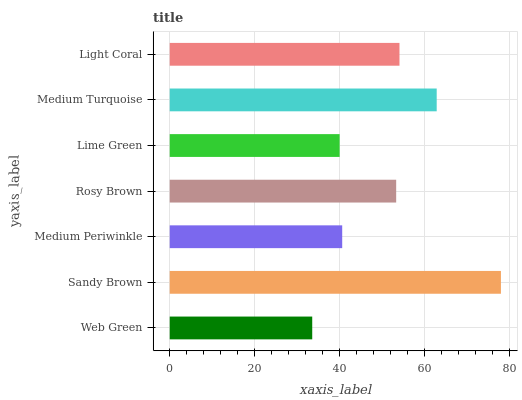Is Web Green the minimum?
Answer yes or no. Yes. Is Sandy Brown the maximum?
Answer yes or no. Yes. Is Medium Periwinkle the minimum?
Answer yes or no. No. Is Medium Periwinkle the maximum?
Answer yes or no. No. Is Sandy Brown greater than Medium Periwinkle?
Answer yes or no. Yes. Is Medium Periwinkle less than Sandy Brown?
Answer yes or no. Yes. Is Medium Periwinkle greater than Sandy Brown?
Answer yes or no. No. Is Sandy Brown less than Medium Periwinkle?
Answer yes or no. No. Is Rosy Brown the high median?
Answer yes or no. Yes. Is Rosy Brown the low median?
Answer yes or no. Yes. Is Medium Turquoise the high median?
Answer yes or no. No. Is Medium Turquoise the low median?
Answer yes or no. No. 